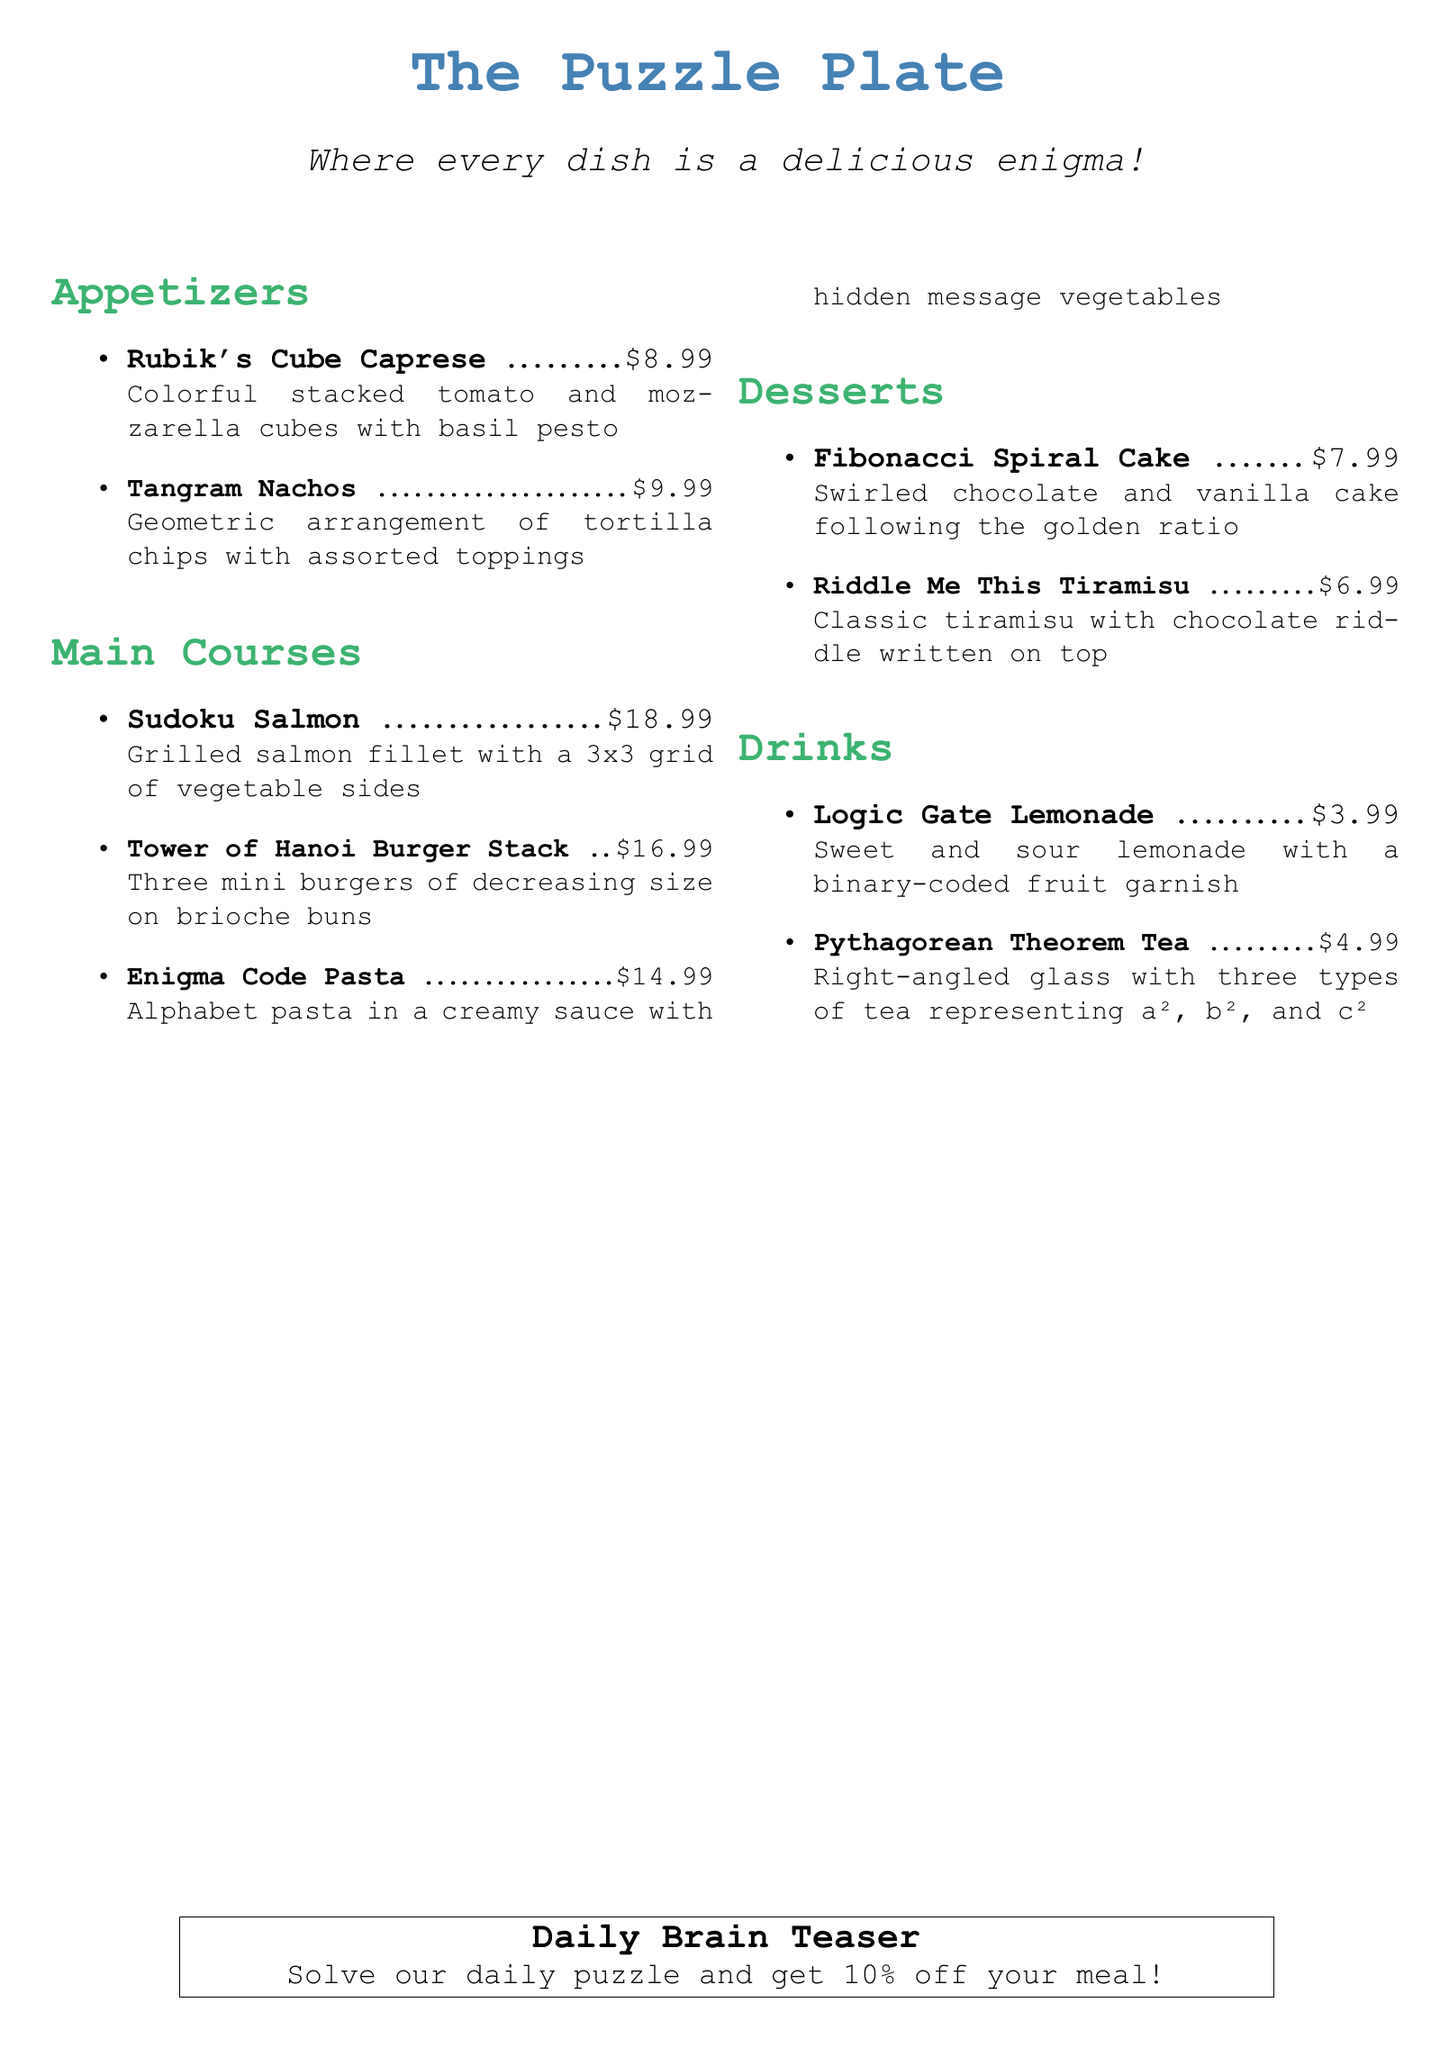What is the name of the appetizer that features tomato and mozzarella? The appetizer featuring tomato and mozzarella is called "Rubik's Cube Caprese".
Answer: Rubik's Cube Caprese How much does the Tower of Hanoi Burger Stack cost? The cost of the Tower of Hanoi Burger Stack is listed in the document as $16.99.
Answer: $16.99 What type of lemonade is offered on the drink menu? The drink menu includes "Logic Gate Lemonade" which has a sweet and sour flavor.
Answer: Logic Gate Lemonade How many mini burgers are in the Tower of Hanoi Burger Stack? The Tower of Hanoi Burger Stack consists of three mini burgers of decreasing size.
Answer: Three What is the dessert that has a chocolate riddle written on top? The dessert that features a chocolate riddle written on top is called "Riddle Me This Tiramisu".
Answer: Riddle Me This Tiramisu Which dish includes hidden message vegetables? The dish that includes hidden message vegetables is "Enigma Code Pasta".
Answer: Enigma Code Pasta What is the promotion for solving the daily puzzle? The promotion for solving the daily puzzle is a discount of 10% off your meal.
Answer: 10% off How is the Fibonacci Spiral Cake described in terms of its design? The Fibonacci Spiral Cake is described as being swirled chocolate and vanilla cake following the golden ratio.
Answer: Golden ratio What does the Pythagorean Theorem Tea represent? The Pythagorean Theorem Tea represents a², b², and c² with three types of tea.
Answer: a², b², and c² 